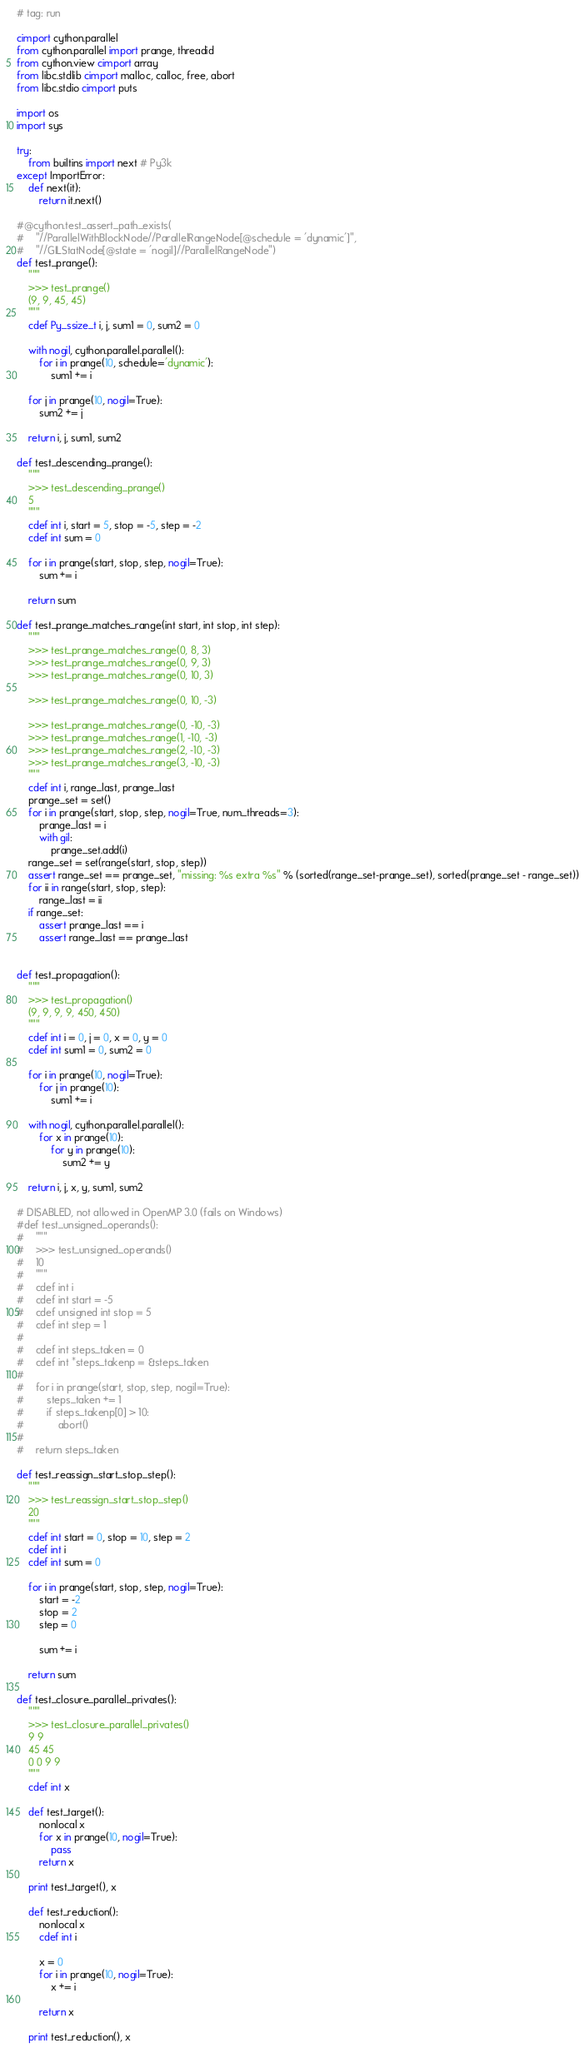<code> <loc_0><loc_0><loc_500><loc_500><_Cython_># tag: run

cimport cython.parallel
from cython.parallel import prange, threadid
from cython.view cimport array
from libc.stdlib cimport malloc, calloc, free, abort
from libc.stdio cimport puts

import os
import sys

try:
    from builtins import next # Py3k
except ImportError:
    def next(it):
        return it.next()

#@cython.test_assert_path_exists(
#    "//ParallelWithBlockNode//ParallelRangeNode[@schedule = 'dynamic']",
#    "//GILStatNode[@state = 'nogil]//ParallelRangeNode")
def test_prange():
    """
    >>> test_prange()
    (9, 9, 45, 45)
    """
    cdef Py_ssize_t i, j, sum1 = 0, sum2 = 0

    with nogil, cython.parallel.parallel():
        for i in prange(10, schedule='dynamic'):
            sum1 += i

    for j in prange(10, nogil=True):
        sum2 += j

    return i, j, sum1, sum2

def test_descending_prange():
    """
    >>> test_descending_prange()
    5
    """
    cdef int i, start = 5, stop = -5, step = -2
    cdef int sum = 0

    for i in prange(start, stop, step, nogil=True):
        sum += i

    return sum

def test_prange_matches_range(int start, int stop, int step):
    """
    >>> test_prange_matches_range(0, 8, 3)
    >>> test_prange_matches_range(0, 9, 3)
    >>> test_prange_matches_range(0, 10, 3)

    >>> test_prange_matches_range(0, 10, -3)

    >>> test_prange_matches_range(0, -10, -3)
    >>> test_prange_matches_range(1, -10, -3)
    >>> test_prange_matches_range(2, -10, -3)
    >>> test_prange_matches_range(3, -10, -3)
    """
    cdef int i, range_last, prange_last
    prange_set = set()
    for i in prange(start, stop, step, nogil=True, num_threads=3):
        prange_last = i
        with gil:
            prange_set.add(i)
    range_set = set(range(start, stop, step))
    assert range_set == prange_set, "missing: %s extra %s" % (sorted(range_set-prange_set), sorted(prange_set - range_set))
    for ii in range(start, stop, step):
        range_last = ii
    if range_set:
        assert prange_last == i
        assert range_last == prange_last


def test_propagation():
    """
    >>> test_propagation()
    (9, 9, 9, 9, 450, 450)
    """
    cdef int i = 0, j = 0, x = 0, y = 0
    cdef int sum1 = 0, sum2 = 0

    for i in prange(10, nogil=True):
        for j in prange(10):
            sum1 += i

    with nogil, cython.parallel.parallel():
        for x in prange(10):
            for y in prange(10):
                sum2 += y

    return i, j, x, y, sum1, sum2

# DISABLED, not allowed in OpenMP 3.0 (fails on Windows)
#def test_unsigned_operands():
#    """
#    >>> test_unsigned_operands()
#    10
#    """
#    cdef int i
#    cdef int start = -5
#    cdef unsigned int stop = 5
#    cdef int step = 1
#
#    cdef int steps_taken = 0
#    cdef int *steps_takenp = &steps_taken
#
#    for i in prange(start, stop, step, nogil=True):
#        steps_taken += 1
#        if steps_takenp[0] > 10:
#            abort()
#
#    return steps_taken

def test_reassign_start_stop_step():
    """
    >>> test_reassign_start_stop_step()
    20
    """
    cdef int start = 0, stop = 10, step = 2
    cdef int i
    cdef int sum = 0

    for i in prange(start, stop, step, nogil=True):
        start = -2
        stop = 2
        step = 0

        sum += i

    return sum

def test_closure_parallel_privates():
    """
    >>> test_closure_parallel_privates()
    9 9
    45 45
    0 0 9 9
    """
    cdef int x

    def test_target():
        nonlocal x
        for x in prange(10, nogil=True):
            pass
        return x

    print test_target(), x

    def test_reduction():
        nonlocal x
        cdef int i

        x = 0
        for i in prange(10, nogil=True):
            x += i

        return x

    print test_reduction(), x
</code> 